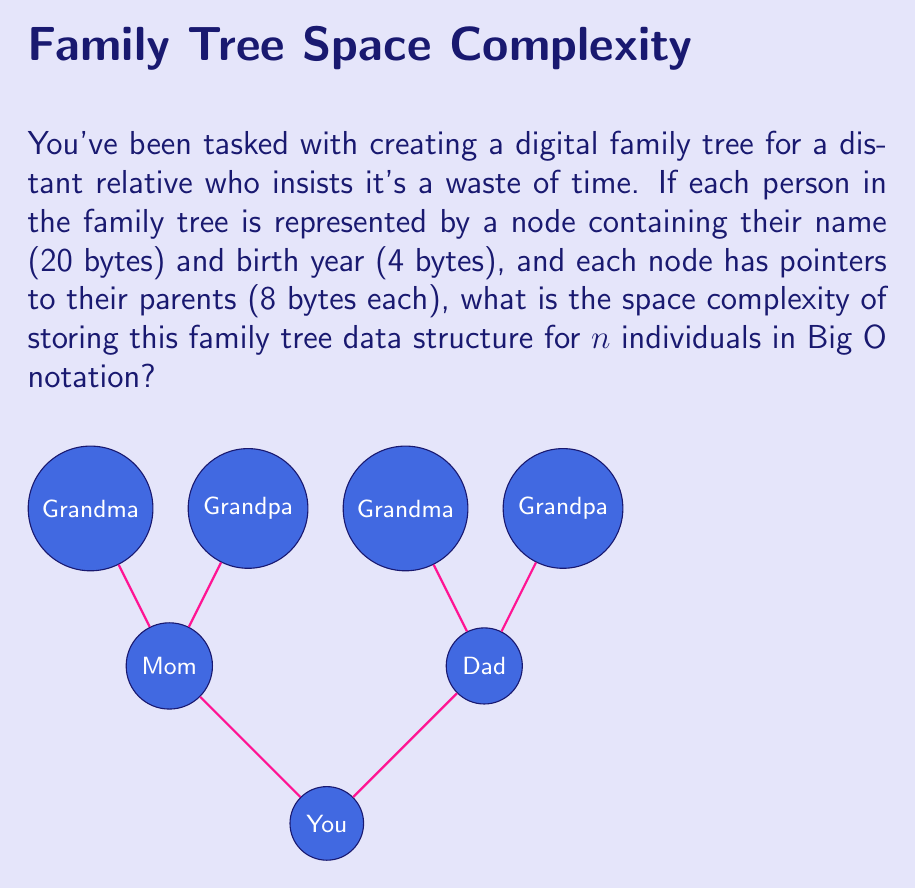Help me with this question. Let's break this down step-by-step:

1) For each person in the family tree, we need to store:
   - Name: 20 bytes
   - Birth year: 4 bytes
   - Pointer to mother: 8 bytes
   - Pointer to father: 8 bytes

2) Total storage per person = 20 + 4 + 8 + 8 = 40 bytes

3) If we have $n$ individuals in the family tree, the total storage required would be:
   $$ \text{Total storage} = 40n \text{ bytes} $$

4) In Big O notation, we drop constants. So, 40n becomes simply n.

5) Therefore, the space complexity is $O(n)$, where $n$ is the number of individuals in the family tree.

This linear space complexity holds true regardless of the structure of the family tree (whether it's deep or wide), as we're only concerned with the total number of individuals, not their relationships.
Answer: $O(n)$ 